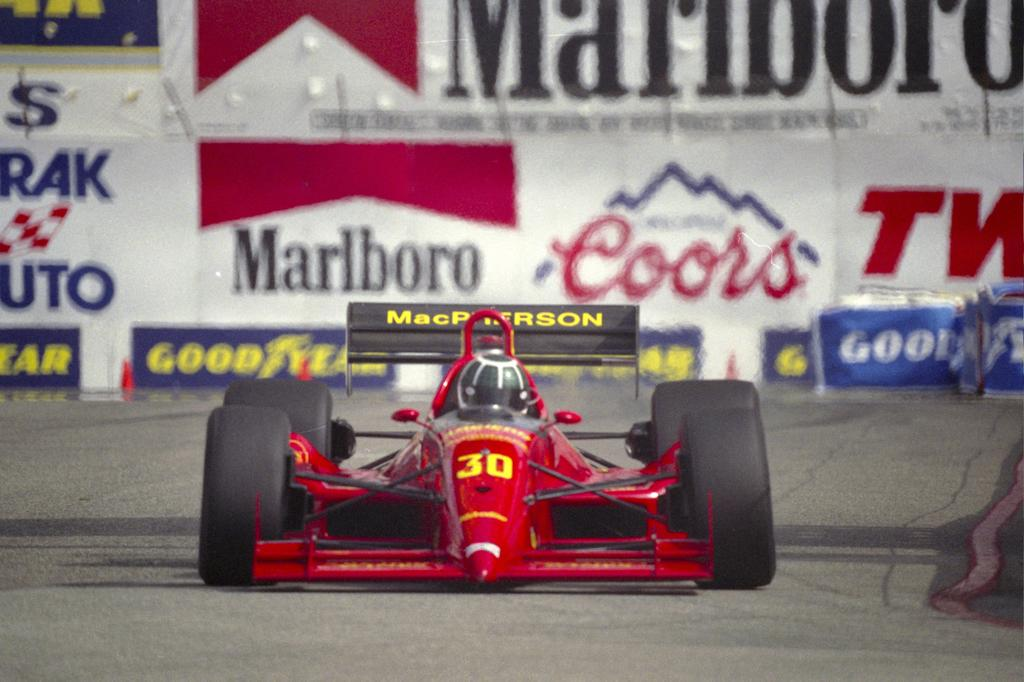What is the main subject of the image? The main subject of the image is a racing car. Where is the racing car located in the image? The racing car is on the road in the image. What can be seen behind the racing car? There are sponsor names behind the car in the image. What is the color of the racing car? The racing car is red in color. Can you hear the yak playing the drum in the image? There is no yak or drum present in the image; it features a racing car on the road. 